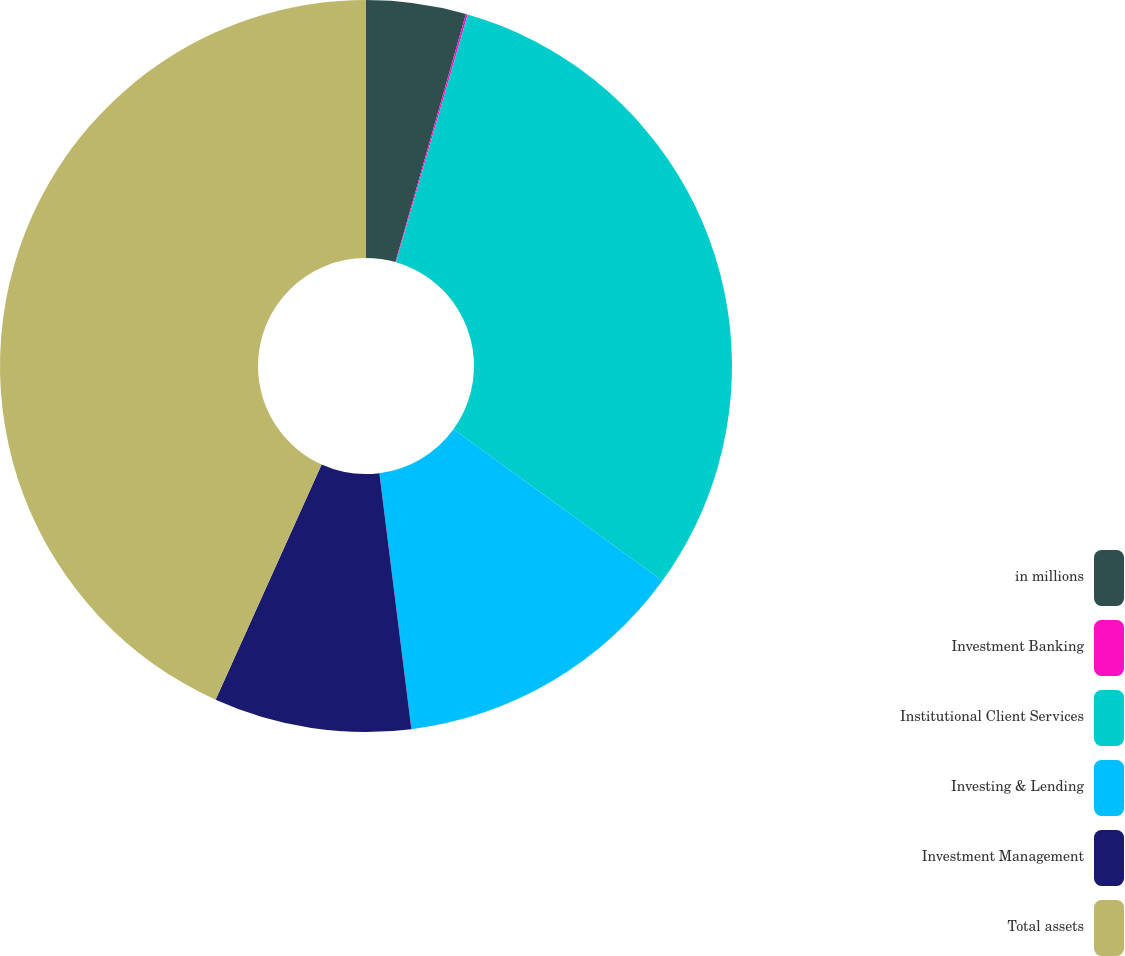Convert chart to OTSL. <chart><loc_0><loc_0><loc_500><loc_500><pie_chart><fcel>in millions<fcel>Investment Banking<fcel>Institutional Client Services<fcel>Investing & Lending<fcel>Investment Management<fcel>Total assets<nl><fcel>4.4%<fcel>0.08%<fcel>30.5%<fcel>13.04%<fcel>8.72%<fcel>43.26%<nl></chart> 